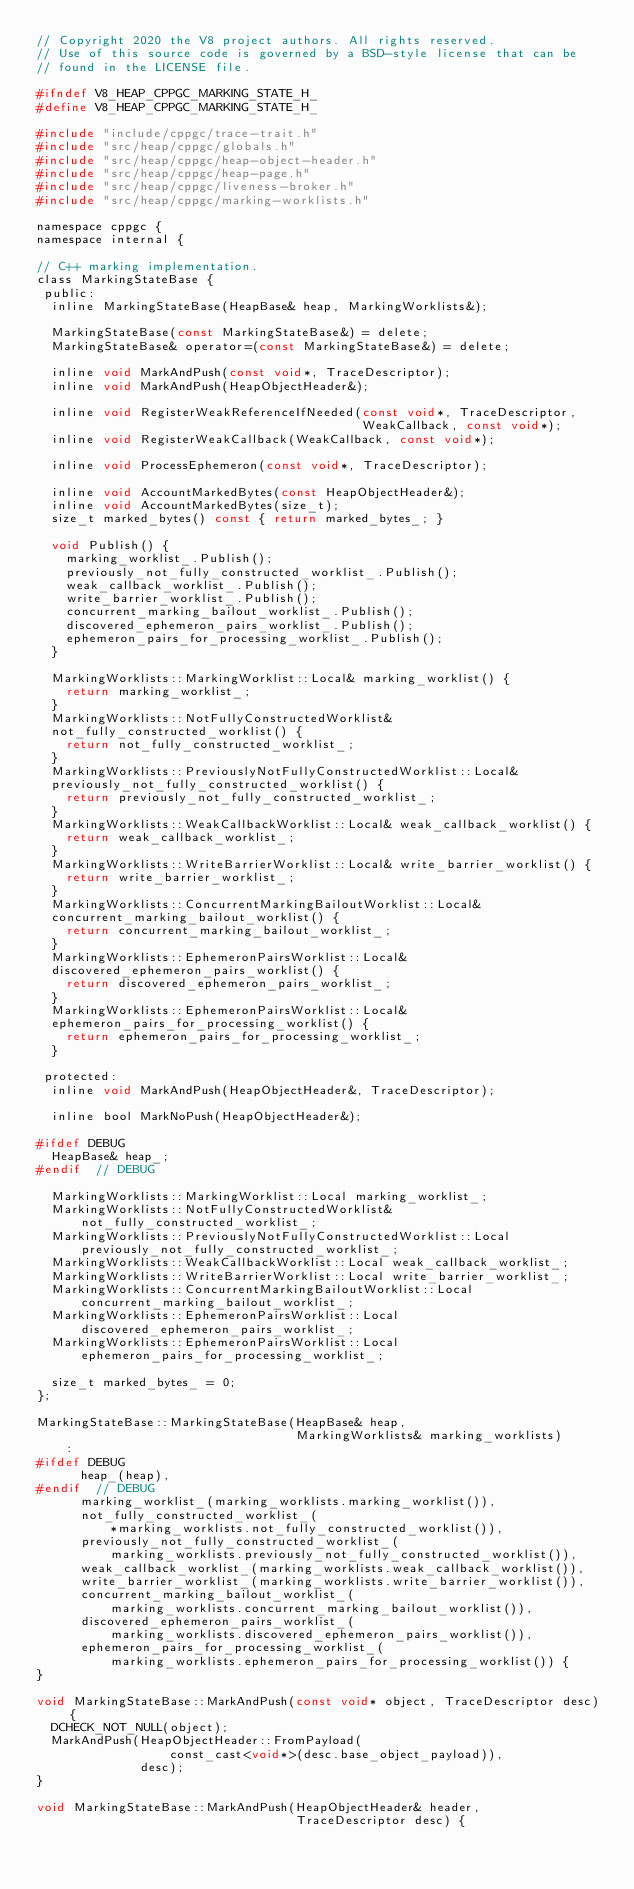<code> <loc_0><loc_0><loc_500><loc_500><_C_>// Copyright 2020 the V8 project authors. All rights reserved.
// Use of this source code is governed by a BSD-style license that can be
// found in the LICENSE file.

#ifndef V8_HEAP_CPPGC_MARKING_STATE_H_
#define V8_HEAP_CPPGC_MARKING_STATE_H_

#include "include/cppgc/trace-trait.h"
#include "src/heap/cppgc/globals.h"
#include "src/heap/cppgc/heap-object-header.h"
#include "src/heap/cppgc/heap-page.h"
#include "src/heap/cppgc/liveness-broker.h"
#include "src/heap/cppgc/marking-worklists.h"

namespace cppgc {
namespace internal {

// C++ marking implementation.
class MarkingStateBase {
 public:
  inline MarkingStateBase(HeapBase& heap, MarkingWorklists&);

  MarkingStateBase(const MarkingStateBase&) = delete;
  MarkingStateBase& operator=(const MarkingStateBase&) = delete;

  inline void MarkAndPush(const void*, TraceDescriptor);
  inline void MarkAndPush(HeapObjectHeader&);

  inline void RegisterWeakReferenceIfNeeded(const void*, TraceDescriptor,
                                            WeakCallback, const void*);
  inline void RegisterWeakCallback(WeakCallback, const void*);

  inline void ProcessEphemeron(const void*, TraceDescriptor);

  inline void AccountMarkedBytes(const HeapObjectHeader&);
  inline void AccountMarkedBytes(size_t);
  size_t marked_bytes() const { return marked_bytes_; }

  void Publish() {
    marking_worklist_.Publish();
    previously_not_fully_constructed_worklist_.Publish();
    weak_callback_worklist_.Publish();
    write_barrier_worklist_.Publish();
    concurrent_marking_bailout_worklist_.Publish();
    discovered_ephemeron_pairs_worklist_.Publish();
    ephemeron_pairs_for_processing_worklist_.Publish();
  }

  MarkingWorklists::MarkingWorklist::Local& marking_worklist() {
    return marking_worklist_;
  }
  MarkingWorklists::NotFullyConstructedWorklist&
  not_fully_constructed_worklist() {
    return not_fully_constructed_worklist_;
  }
  MarkingWorklists::PreviouslyNotFullyConstructedWorklist::Local&
  previously_not_fully_constructed_worklist() {
    return previously_not_fully_constructed_worklist_;
  }
  MarkingWorklists::WeakCallbackWorklist::Local& weak_callback_worklist() {
    return weak_callback_worklist_;
  }
  MarkingWorklists::WriteBarrierWorklist::Local& write_barrier_worklist() {
    return write_barrier_worklist_;
  }
  MarkingWorklists::ConcurrentMarkingBailoutWorklist::Local&
  concurrent_marking_bailout_worklist() {
    return concurrent_marking_bailout_worklist_;
  }
  MarkingWorklists::EphemeronPairsWorklist::Local&
  discovered_ephemeron_pairs_worklist() {
    return discovered_ephemeron_pairs_worklist_;
  }
  MarkingWorklists::EphemeronPairsWorklist::Local&
  ephemeron_pairs_for_processing_worklist() {
    return ephemeron_pairs_for_processing_worklist_;
  }

 protected:
  inline void MarkAndPush(HeapObjectHeader&, TraceDescriptor);

  inline bool MarkNoPush(HeapObjectHeader&);

#ifdef DEBUG
  HeapBase& heap_;
#endif  // DEBUG

  MarkingWorklists::MarkingWorklist::Local marking_worklist_;
  MarkingWorklists::NotFullyConstructedWorklist&
      not_fully_constructed_worklist_;
  MarkingWorklists::PreviouslyNotFullyConstructedWorklist::Local
      previously_not_fully_constructed_worklist_;
  MarkingWorklists::WeakCallbackWorklist::Local weak_callback_worklist_;
  MarkingWorklists::WriteBarrierWorklist::Local write_barrier_worklist_;
  MarkingWorklists::ConcurrentMarkingBailoutWorklist::Local
      concurrent_marking_bailout_worklist_;
  MarkingWorklists::EphemeronPairsWorklist::Local
      discovered_ephemeron_pairs_worklist_;
  MarkingWorklists::EphemeronPairsWorklist::Local
      ephemeron_pairs_for_processing_worklist_;

  size_t marked_bytes_ = 0;
};

MarkingStateBase::MarkingStateBase(HeapBase& heap,
                                   MarkingWorklists& marking_worklists)
    :
#ifdef DEBUG
      heap_(heap),
#endif  // DEBUG
      marking_worklist_(marking_worklists.marking_worklist()),
      not_fully_constructed_worklist_(
          *marking_worklists.not_fully_constructed_worklist()),
      previously_not_fully_constructed_worklist_(
          marking_worklists.previously_not_fully_constructed_worklist()),
      weak_callback_worklist_(marking_worklists.weak_callback_worklist()),
      write_barrier_worklist_(marking_worklists.write_barrier_worklist()),
      concurrent_marking_bailout_worklist_(
          marking_worklists.concurrent_marking_bailout_worklist()),
      discovered_ephemeron_pairs_worklist_(
          marking_worklists.discovered_ephemeron_pairs_worklist()),
      ephemeron_pairs_for_processing_worklist_(
          marking_worklists.ephemeron_pairs_for_processing_worklist()) {
}

void MarkingStateBase::MarkAndPush(const void* object, TraceDescriptor desc) {
  DCHECK_NOT_NULL(object);
  MarkAndPush(HeapObjectHeader::FromPayload(
                  const_cast<void*>(desc.base_object_payload)),
              desc);
}

void MarkingStateBase::MarkAndPush(HeapObjectHeader& header,
                                   TraceDescriptor desc) {</code> 